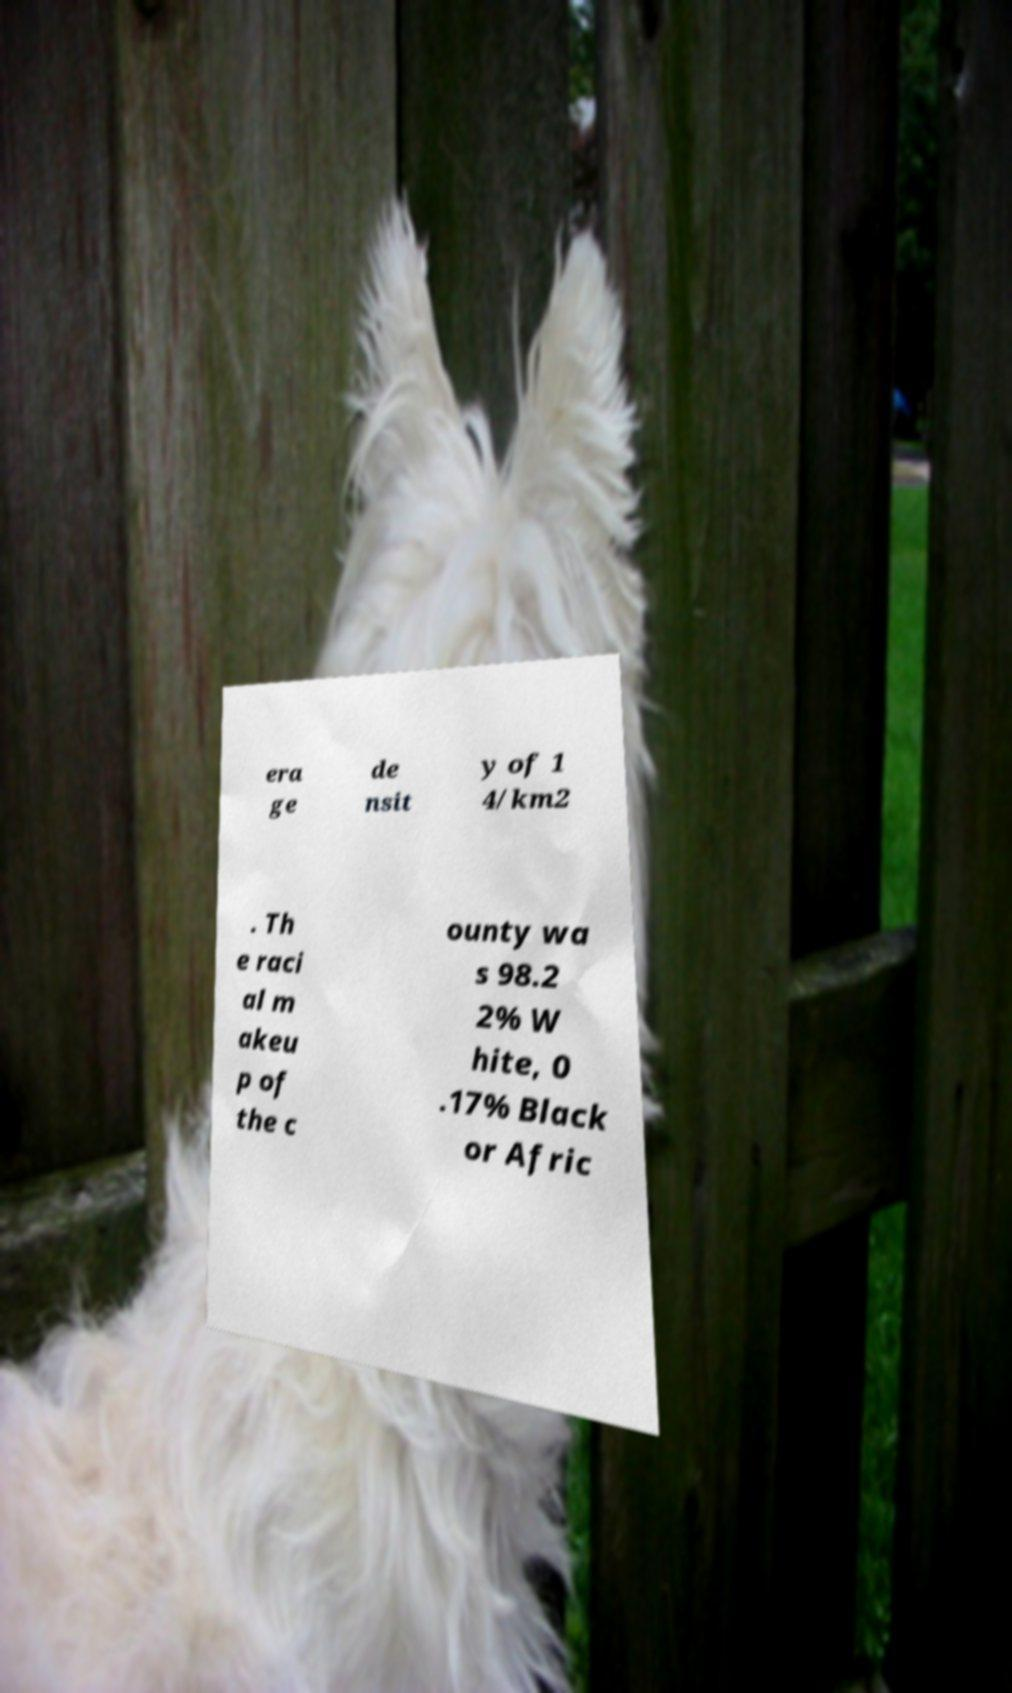For documentation purposes, I need the text within this image transcribed. Could you provide that? era ge de nsit y of 1 4/km2 . Th e raci al m akeu p of the c ounty wa s 98.2 2% W hite, 0 .17% Black or Afric 